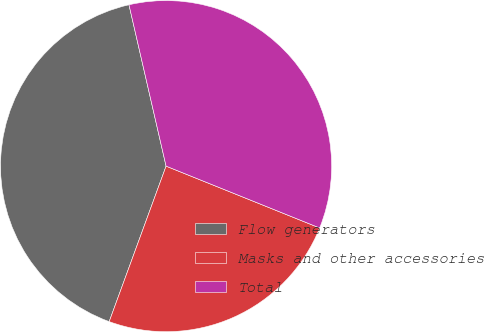Convert chart to OTSL. <chart><loc_0><loc_0><loc_500><loc_500><pie_chart><fcel>Flow generators<fcel>Masks and other accessories<fcel>Total<nl><fcel>40.82%<fcel>24.49%<fcel>34.69%<nl></chart> 